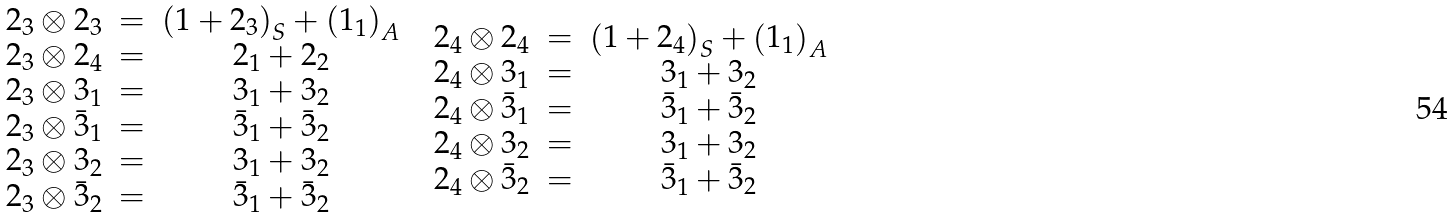<formula> <loc_0><loc_0><loc_500><loc_500>\begin{array} { c c } \begin{array} { c c c } { 2 _ { 3 } } \otimes { 2 _ { 3 } } & = & \left ( { 1 } + { 2 _ { 3 } } \right ) _ { S } + \left ( { 1 _ { 1 } } \right ) _ { A } \\ { 2 _ { 3 } } \otimes { 2 _ { 4 } } & = & { 2 _ { 1 } } + { 2 _ { 2 } } \\ { 2 _ { 3 } } \otimes { 3 _ { 1 } } & = & { 3 _ { 1 } } + { 3 _ { 2 } } \\ { 2 _ { 3 } } \otimes { \bar { 3 } _ { 1 } } & = & { \bar { 3 } _ { 1 } } + { \bar { 3 } _ { 2 } } \\ { 2 _ { 3 } } \otimes { 3 _ { 2 } } & = & { 3 _ { 1 } } + { 3 _ { 2 } } \\ { 2 _ { 3 } } \otimes { \bar { 3 } _ { 2 } } & = & { \bar { 3 } _ { 1 } } + { \bar { 3 } _ { 2 } } \\ \end{array} & \begin{array} { c c c } { 2 _ { 4 } } \otimes { 2 _ { 4 } } & = & \left ( { 1 } + { 2 _ { 4 } } \right ) _ { S } + \left ( { 1 _ { 1 } } \right ) _ { A } \\ { 2 _ { 4 } } \otimes { 3 _ { 1 } } & = & { 3 _ { 1 } } + { 3 _ { 2 } } \\ { 2 _ { 4 } } \otimes { \bar { 3 } _ { 1 } } & = & { \bar { 3 } _ { 1 } } + { \bar { 3 } _ { 2 } } \\ { 2 _ { 4 } } \otimes { 3 _ { 2 } } & = & { 3 _ { 1 } } + { 3 _ { 2 } } \\ { 2 _ { 4 } } \otimes { \bar { 3 } _ { 2 } } & = & { \bar { 3 } _ { 1 } } + { \bar { 3 } _ { 2 } } \\ \end{array} \end{array}</formula> 